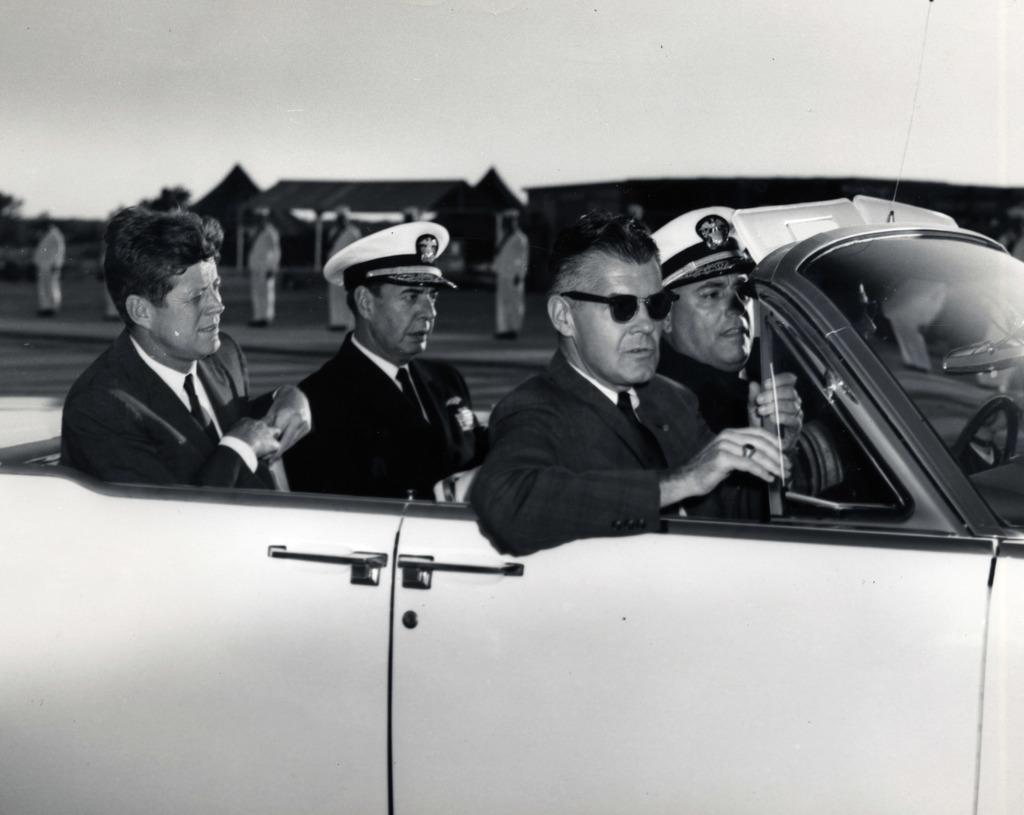In one or two sentences, can you explain what this image depicts? In a car there are four men sitting. To the right side of the car there are two men with white color cap on their head. And behind them there are some people standing with white color dress. In the background there are some huts. 